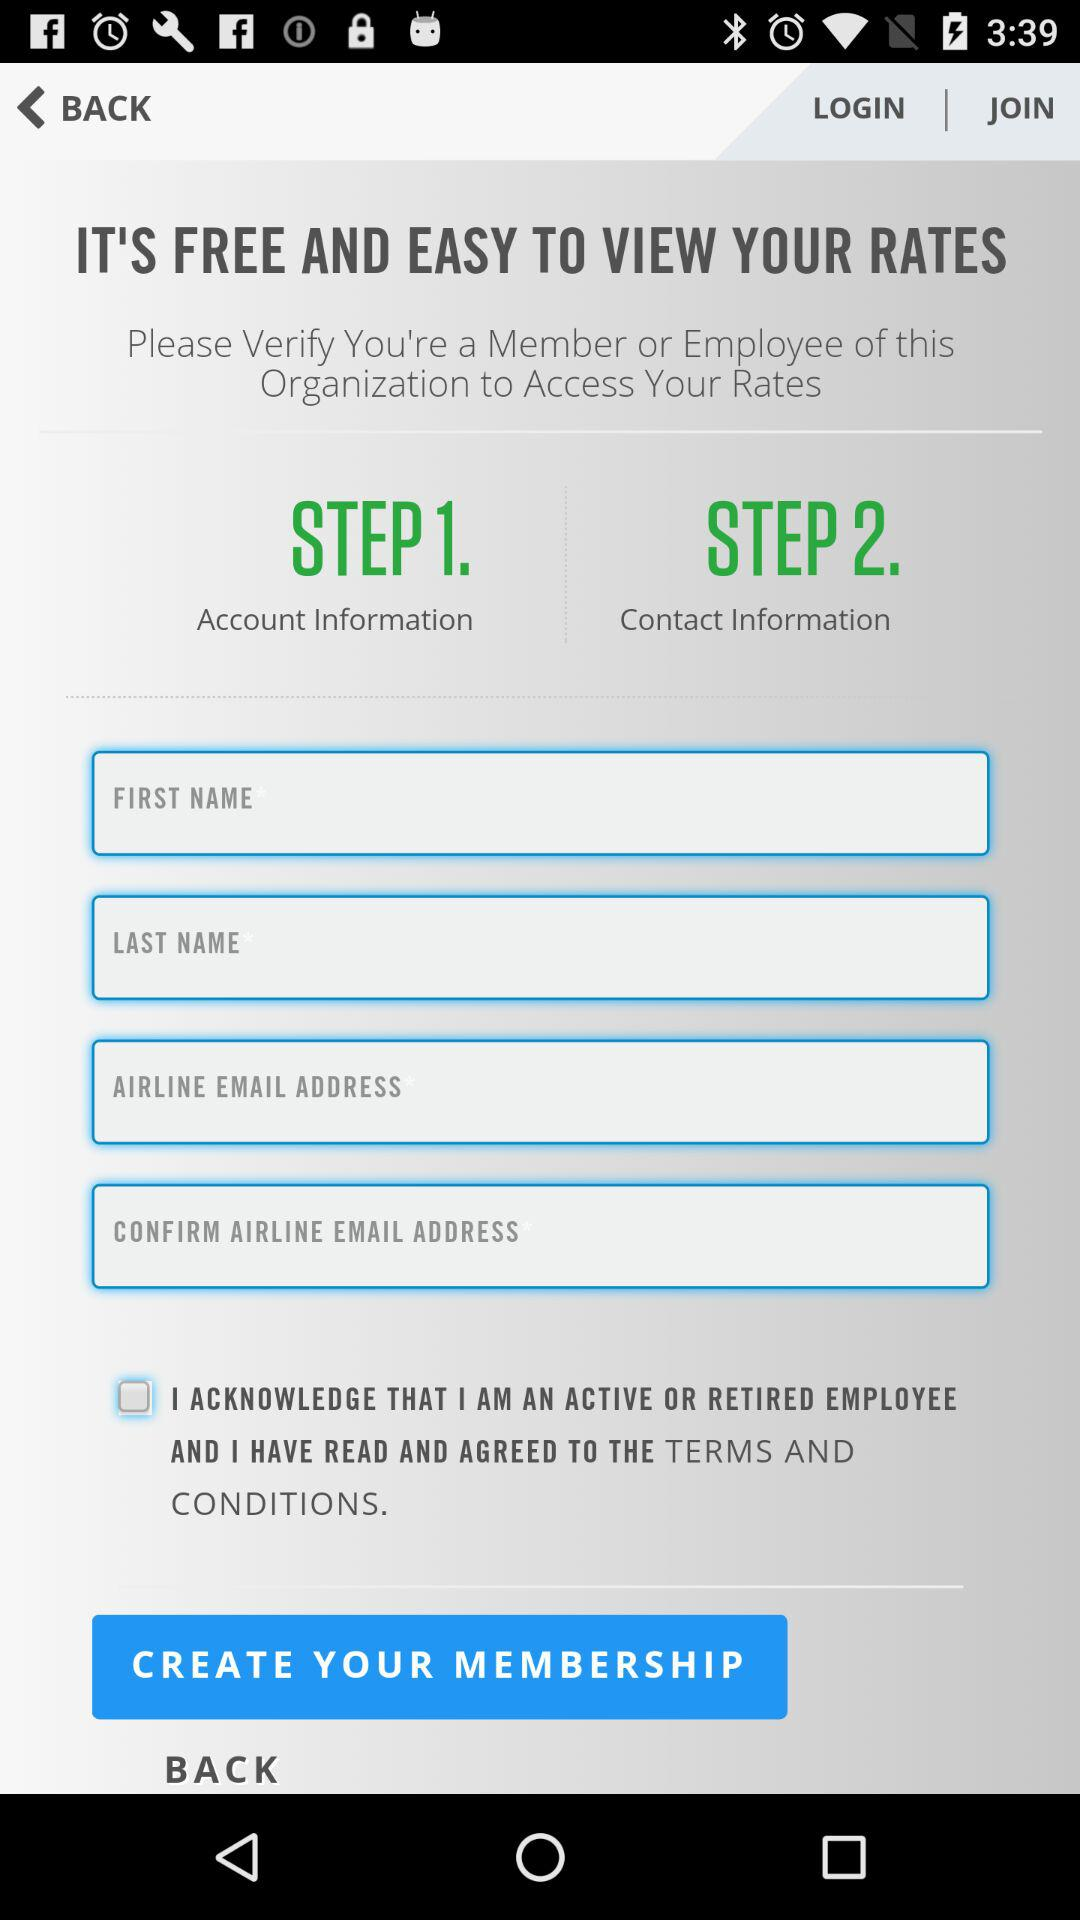How many steps are there in the process?
Answer the question using a single word or phrase. 2 